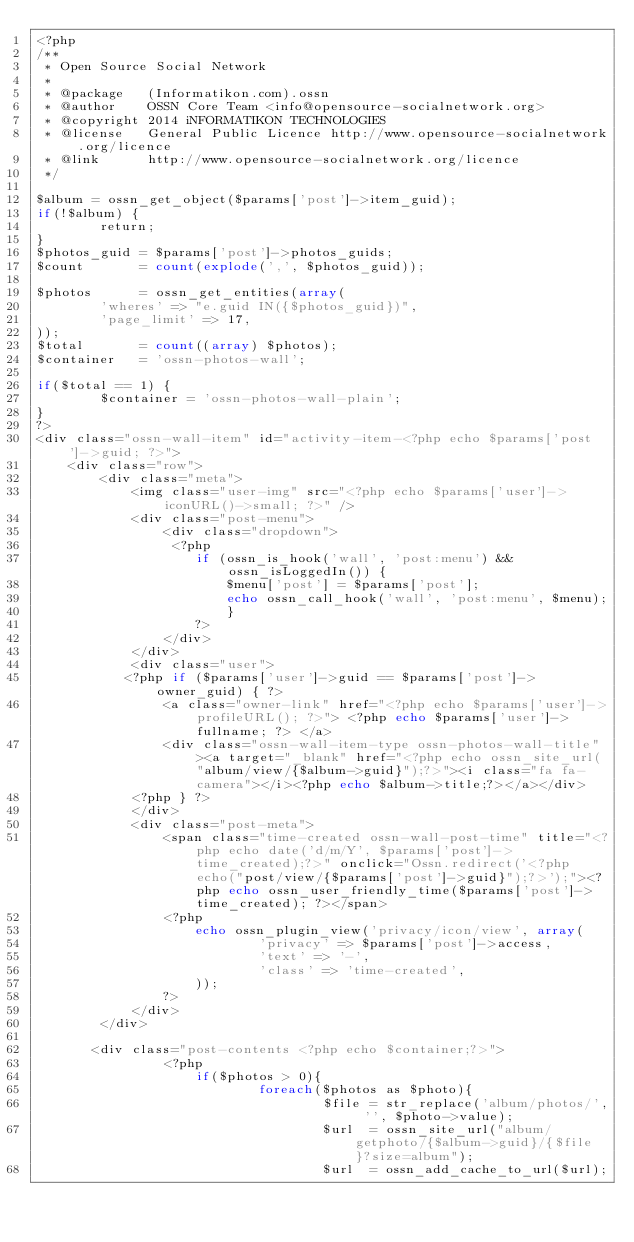<code> <loc_0><loc_0><loc_500><loc_500><_PHP_><?php
/**
 * Open Source Social Network
 *
 * @package   (Informatikon.com).ossn
 * @author    OSSN Core Team <info@opensource-socialnetwork.org>
 * @copyright 2014 iNFORMATIKON TECHNOLOGIES
 * @license   General Public Licence http://www.opensource-socialnetwork.org/licence
 * @link      http://www.opensource-socialnetwork.org/licence
 */

$album = ossn_get_object($params['post']->item_guid);
if(!$album) {
		return;
}
$photos_guid = $params['post']->photos_guids;
$count  	 = count(explode(',', $photos_guid));

$photos      = ossn_get_entities(array(
		'wheres' => "e.guid IN({$photos_guid})",
		'page_limit' => 17,
));
$total       = count((array) $photos);
$container   = 'ossn-photos-wall';

if($total == 1) {
		$container = 'ossn-photos-wall-plain';
}
?>
<div class="ossn-wall-item" id="activity-item-<?php echo $params['post']->guid; ?>">
	<div class="row">
		<div class="meta">
			<img class="user-img" src="<?php echo $params['user']->iconURL()->small; ?>" />
			<div class="post-menu">
				<div class="dropdown">
                 <?php
           			if (ossn_is_hook('wall', 'post:menu') && ossn_isLoggedIn()) {
                		$menu['post'] = $params['post'];
               			echo ossn_call_hook('wall', 'post:menu', $menu);
            			}
            		?>   
				</div>
			</div>
			<div class="user">
           <?php if ($params['user']->guid == $params['post']->owner_guid) { ?>
                <a class="owner-link" href="<?php echo $params['user']->profileURL(); ?>"> <?php echo $params['user']->fullname; ?> </a>
                <div class="ossn-wall-item-type ossn-photos-wall-title"><a target="_blank" href="<?php echo ossn_site_url("album/view/{$album->guid}");?>"><i class="fa fa-camera"></i><?php echo $album->title;?></a></div>
            <?php } ?>
			</div>
			<div class="post-meta">
				<span class="time-created ossn-wall-post-time" title="<?php echo date('d/m/Y', $params['post']->time_created);?>" onclick="Ossn.redirect('<?php echo("post/view/{$params['post']->guid}");?>');"><?php echo ossn_user_friendly_time($params['post']->time_created); ?></span>
				<?php
					echo ossn_plugin_view('privacy/icon/view', array(
							'privacy' => $params['post']->access,
							'text' => '-',
							'class' => 'time-created',
					));
				?>                
			</div>
		</div>

       <div class="post-contents <?php echo $container;?>">
				<?php
					if($photos > 0){
							foreach($photos as $photo){
									$file = str_replace('album/photos/', '', $photo->value);
									$url  = ossn_site_url("album/getphoto/{$album->guid}/{$file}?size=album");		
									$url  = ossn_add_cache_to_url($url);</code> 